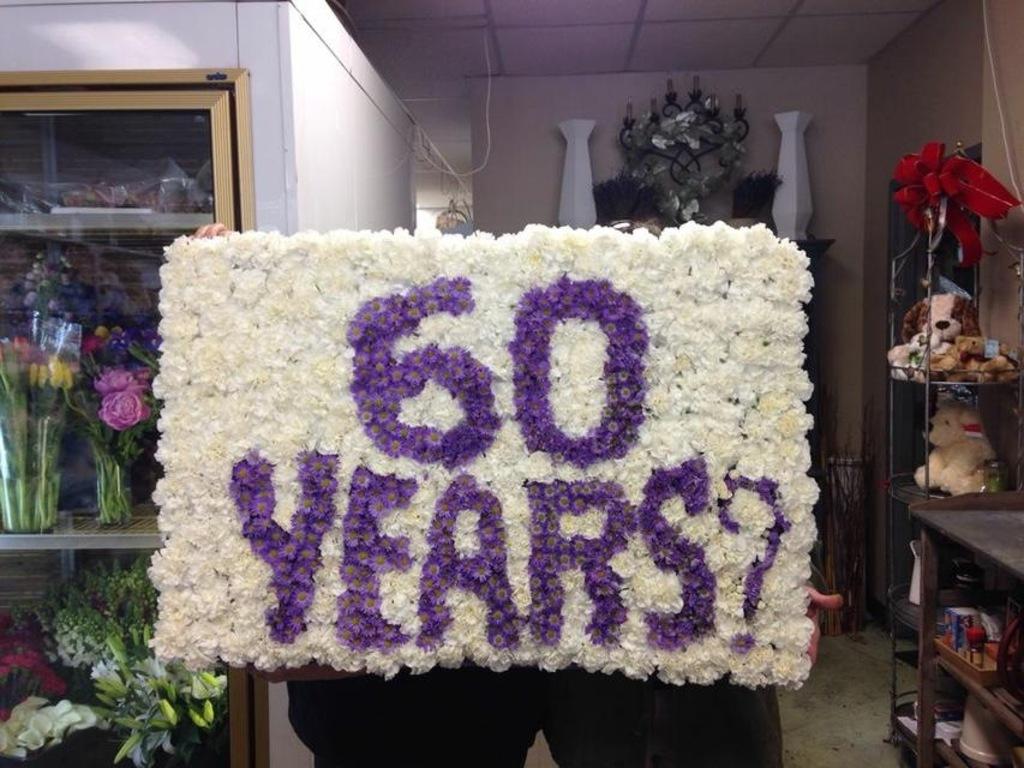How many years has it been?
Keep it short and to the point. 60. Is the text purple?
Give a very brief answer. Yes. 